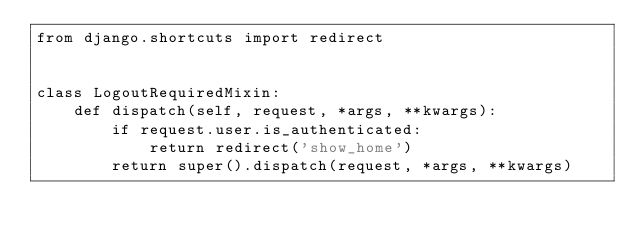Convert code to text. <code><loc_0><loc_0><loc_500><loc_500><_Python_>from django.shortcuts import redirect


class LogoutRequiredMixin:
    def dispatch(self, request, *args, **kwargs):
        if request.user.is_authenticated:
            return redirect('show_home')
        return super().dispatch(request, *args, **kwargs)
</code> 